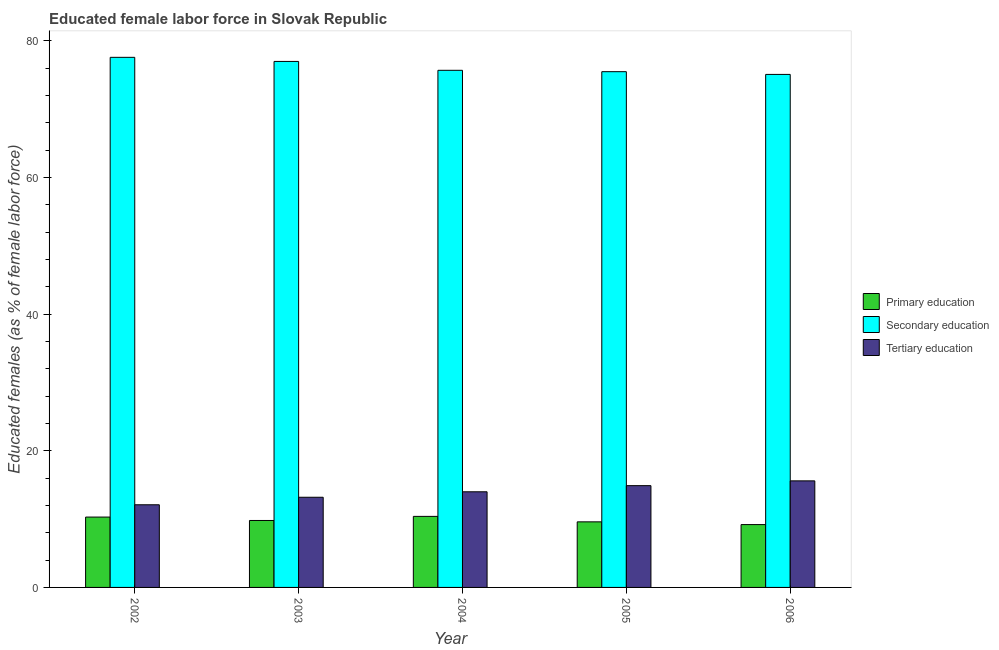How many different coloured bars are there?
Your answer should be very brief. 3. Are the number of bars per tick equal to the number of legend labels?
Offer a very short reply. Yes. Are the number of bars on each tick of the X-axis equal?
Offer a terse response. Yes. How many bars are there on the 5th tick from the left?
Your answer should be compact. 3. How many bars are there on the 4th tick from the right?
Your response must be concise. 3. What is the percentage of female labor force who received primary education in 2006?
Your answer should be compact. 9.2. Across all years, what is the maximum percentage of female labor force who received secondary education?
Give a very brief answer. 77.6. Across all years, what is the minimum percentage of female labor force who received secondary education?
Your response must be concise. 75.1. In which year was the percentage of female labor force who received primary education maximum?
Give a very brief answer. 2004. What is the total percentage of female labor force who received primary education in the graph?
Keep it short and to the point. 49.3. What is the difference between the percentage of female labor force who received secondary education in 2003 and that in 2006?
Keep it short and to the point. 1.9. What is the difference between the percentage of female labor force who received secondary education in 2004 and the percentage of female labor force who received primary education in 2005?
Keep it short and to the point. 0.2. What is the average percentage of female labor force who received tertiary education per year?
Provide a succinct answer. 13.96. In the year 2002, what is the difference between the percentage of female labor force who received tertiary education and percentage of female labor force who received secondary education?
Keep it short and to the point. 0. In how many years, is the percentage of female labor force who received tertiary education greater than 24 %?
Your answer should be very brief. 0. What is the ratio of the percentage of female labor force who received primary education in 2003 to that in 2006?
Give a very brief answer. 1.07. What is the difference between the highest and the second highest percentage of female labor force who received tertiary education?
Make the answer very short. 0.7. What is the difference between the highest and the lowest percentage of female labor force who received secondary education?
Make the answer very short. 2.5. What does the 3rd bar from the left in 2004 represents?
Provide a short and direct response. Tertiary education. What is the difference between two consecutive major ticks on the Y-axis?
Your answer should be very brief. 20. Are the values on the major ticks of Y-axis written in scientific E-notation?
Ensure brevity in your answer.  No. Does the graph contain grids?
Your response must be concise. No. How many legend labels are there?
Your answer should be very brief. 3. What is the title of the graph?
Your answer should be compact. Educated female labor force in Slovak Republic. What is the label or title of the X-axis?
Provide a succinct answer. Year. What is the label or title of the Y-axis?
Your response must be concise. Educated females (as % of female labor force). What is the Educated females (as % of female labor force) of Primary education in 2002?
Give a very brief answer. 10.3. What is the Educated females (as % of female labor force) of Secondary education in 2002?
Ensure brevity in your answer.  77.6. What is the Educated females (as % of female labor force) of Tertiary education in 2002?
Your response must be concise. 12.1. What is the Educated females (as % of female labor force) in Primary education in 2003?
Offer a terse response. 9.8. What is the Educated females (as % of female labor force) in Secondary education in 2003?
Give a very brief answer. 77. What is the Educated females (as % of female labor force) in Tertiary education in 2003?
Make the answer very short. 13.2. What is the Educated females (as % of female labor force) in Primary education in 2004?
Give a very brief answer. 10.4. What is the Educated females (as % of female labor force) of Secondary education in 2004?
Ensure brevity in your answer.  75.7. What is the Educated females (as % of female labor force) of Tertiary education in 2004?
Offer a terse response. 14. What is the Educated females (as % of female labor force) of Primary education in 2005?
Your answer should be compact. 9.6. What is the Educated females (as % of female labor force) of Secondary education in 2005?
Your answer should be compact. 75.5. What is the Educated females (as % of female labor force) in Tertiary education in 2005?
Your answer should be very brief. 14.9. What is the Educated females (as % of female labor force) of Primary education in 2006?
Offer a terse response. 9.2. What is the Educated females (as % of female labor force) of Secondary education in 2006?
Offer a very short reply. 75.1. What is the Educated females (as % of female labor force) in Tertiary education in 2006?
Give a very brief answer. 15.6. Across all years, what is the maximum Educated females (as % of female labor force) in Primary education?
Provide a succinct answer. 10.4. Across all years, what is the maximum Educated females (as % of female labor force) of Secondary education?
Offer a terse response. 77.6. Across all years, what is the maximum Educated females (as % of female labor force) of Tertiary education?
Offer a terse response. 15.6. Across all years, what is the minimum Educated females (as % of female labor force) of Primary education?
Ensure brevity in your answer.  9.2. Across all years, what is the minimum Educated females (as % of female labor force) in Secondary education?
Your answer should be very brief. 75.1. Across all years, what is the minimum Educated females (as % of female labor force) in Tertiary education?
Your response must be concise. 12.1. What is the total Educated females (as % of female labor force) of Primary education in the graph?
Keep it short and to the point. 49.3. What is the total Educated females (as % of female labor force) of Secondary education in the graph?
Your answer should be very brief. 380.9. What is the total Educated females (as % of female labor force) of Tertiary education in the graph?
Offer a terse response. 69.8. What is the difference between the Educated females (as % of female labor force) in Primary education in 2002 and that in 2004?
Offer a terse response. -0.1. What is the difference between the Educated females (as % of female labor force) of Secondary education in 2002 and that in 2004?
Provide a succinct answer. 1.9. What is the difference between the Educated females (as % of female labor force) of Primary education in 2002 and that in 2005?
Your response must be concise. 0.7. What is the difference between the Educated females (as % of female labor force) in Secondary education in 2002 and that in 2005?
Offer a terse response. 2.1. What is the difference between the Educated females (as % of female labor force) in Tertiary education in 2002 and that in 2005?
Ensure brevity in your answer.  -2.8. What is the difference between the Educated females (as % of female labor force) in Primary education in 2002 and that in 2006?
Provide a short and direct response. 1.1. What is the difference between the Educated females (as % of female labor force) of Tertiary education in 2002 and that in 2006?
Your answer should be compact. -3.5. What is the difference between the Educated females (as % of female labor force) in Primary education in 2003 and that in 2004?
Offer a very short reply. -0.6. What is the difference between the Educated females (as % of female labor force) in Primary education in 2003 and that in 2005?
Your response must be concise. 0.2. What is the difference between the Educated females (as % of female labor force) of Tertiary education in 2003 and that in 2005?
Provide a short and direct response. -1.7. What is the difference between the Educated females (as % of female labor force) in Primary education in 2003 and that in 2006?
Offer a terse response. 0.6. What is the difference between the Educated females (as % of female labor force) in Secondary education in 2003 and that in 2006?
Provide a short and direct response. 1.9. What is the difference between the Educated females (as % of female labor force) in Tertiary education in 2003 and that in 2006?
Your answer should be very brief. -2.4. What is the difference between the Educated females (as % of female labor force) in Tertiary education in 2004 and that in 2006?
Your answer should be compact. -1.6. What is the difference between the Educated females (as % of female labor force) of Primary education in 2005 and that in 2006?
Your response must be concise. 0.4. What is the difference between the Educated females (as % of female labor force) in Primary education in 2002 and the Educated females (as % of female labor force) in Secondary education in 2003?
Ensure brevity in your answer.  -66.7. What is the difference between the Educated females (as % of female labor force) of Primary education in 2002 and the Educated females (as % of female labor force) of Tertiary education in 2003?
Your answer should be very brief. -2.9. What is the difference between the Educated females (as % of female labor force) of Secondary education in 2002 and the Educated females (as % of female labor force) of Tertiary education in 2003?
Provide a short and direct response. 64.4. What is the difference between the Educated females (as % of female labor force) in Primary education in 2002 and the Educated females (as % of female labor force) in Secondary education in 2004?
Make the answer very short. -65.4. What is the difference between the Educated females (as % of female labor force) of Secondary education in 2002 and the Educated females (as % of female labor force) of Tertiary education in 2004?
Offer a terse response. 63.6. What is the difference between the Educated females (as % of female labor force) of Primary education in 2002 and the Educated females (as % of female labor force) of Secondary education in 2005?
Give a very brief answer. -65.2. What is the difference between the Educated females (as % of female labor force) in Primary education in 2002 and the Educated females (as % of female labor force) in Tertiary education in 2005?
Provide a succinct answer. -4.6. What is the difference between the Educated females (as % of female labor force) of Secondary education in 2002 and the Educated females (as % of female labor force) of Tertiary education in 2005?
Your answer should be very brief. 62.7. What is the difference between the Educated females (as % of female labor force) in Primary education in 2002 and the Educated females (as % of female labor force) in Secondary education in 2006?
Provide a short and direct response. -64.8. What is the difference between the Educated females (as % of female labor force) in Primary education in 2003 and the Educated females (as % of female labor force) in Secondary education in 2004?
Your answer should be compact. -65.9. What is the difference between the Educated females (as % of female labor force) in Secondary education in 2003 and the Educated females (as % of female labor force) in Tertiary education in 2004?
Make the answer very short. 63. What is the difference between the Educated females (as % of female labor force) of Primary education in 2003 and the Educated females (as % of female labor force) of Secondary education in 2005?
Provide a succinct answer. -65.7. What is the difference between the Educated females (as % of female labor force) in Primary education in 2003 and the Educated females (as % of female labor force) in Tertiary education in 2005?
Offer a very short reply. -5.1. What is the difference between the Educated females (as % of female labor force) of Secondary education in 2003 and the Educated females (as % of female labor force) of Tertiary education in 2005?
Provide a short and direct response. 62.1. What is the difference between the Educated females (as % of female labor force) of Primary education in 2003 and the Educated females (as % of female labor force) of Secondary education in 2006?
Ensure brevity in your answer.  -65.3. What is the difference between the Educated females (as % of female labor force) of Primary education in 2003 and the Educated females (as % of female labor force) of Tertiary education in 2006?
Your answer should be compact. -5.8. What is the difference between the Educated females (as % of female labor force) in Secondary education in 2003 and the Educated females (as % of female labor force) in Tertiary education in 2006?
Your answer should be compact. 61.4. What is the difference between the Educated females (as % of female labor force) of Primary education in 2004 and the Educated females (as % of female labor force) of Secondary education in 2005?
Your answer should be compact. -65.1. What is the difference between the Educated females (as % of female labor force) in Secondary education in 2004 and the Educated females (as % of female labor force) in Tertiary education in 2005?
Offer a very short reply. 60.8. What is the difference between the Educated females (as % of female labor force) of Primary education in 2004 and the Educated females (as % of female labor force) of Secondary education in 2006?
Give a very brief answer. -64.7. What is the difference between the Educated females (as % of female labor force) of Primary education in 2004 and the Educated females (as % of female labor force) of Tertiary education in 2006?
Your answer should be very brief. -5.2. What is the difference between the Educated females (as % of female labor force) in Secondary education in 2004 and the Educated females (as % of female labor force) in Tertiary education in 2006?
Keep it short and to the point. 60.1. What is the difference between the Educated females (as % of female labor force) of Primary education in 2005 and the Educated females (as % of female labor force) of Secondary education in 2006?
Offer a terse response. -65.5. What is the difference between the Educated females (as % of female labor force) in Primary education in 2005 and the Educated females (as % of female labor force) in Tertiary education in 2006?
Ensure brevity in your answer.  -6. What is the difference between the Educated females (as % of female labor force) of Secondary education in 2005 and the Educated females (as % of female labor force) of Tertiary education in 2006?
Your answer should be very brief. 59.9. What is the average Educated females (as % of female labor force) in Primary education per year?
Ensure brevity in your answer.  9.86. What is the average Educated females (as % of female labor force) of Secondary education per year?
Offer a terse response. 76.18. What is the average Educated females (as % of female labor force) in Tertiary education per year?
Give a very brief answer. 13.96. In the year 2002, what is the difference between the Educated females (as % of female labor force) in Primary education and Educated females (as % of female labor force) in Secondary education?
Make the answer very short. -67.3. In the year 2002, what is the difference between the Educated females (as % of female labor force) in Secondary education and Educated females (as % of female labor force) in Tertiary education?
Provide a succinct answer. 65.5. In the year 2003, what is the difference between the Educated females (as % of female labor force) in Primary education and Educated females (as % of female labor force) in Secondary education?
Provide a succinct answer. -67.2. In the year 2003, what is the difference between the Educated females (as % of female labor force) in Primary education and Educated females (as % of female labor force) in Tertiary education?
Ensure brevity in your answer.  -3.4. In the year 2003, what is the difference between the Educated females (as % of female labor force) of Secondary education and Educated females (as % of female labor force) of Tertiary education?
Your answer should be compact. 63.8. In the year 2004, what is the difference between the Educated females (as % of female labor force) of Primary education and Educated females (as % of female labor force) of Secondary education?
Your response must be concise. -65.3. In the year 2004, what is the difference between the Educated females (as % of female labor force) in Primary education and Educated females (as % of female labor force) in Tertiary education?
Your response must be concise. -3.6. In the year 2004, what is the difference between the Educated females (as % of female labor force) in Secondary education and Educated females (as % of female labor force) in Tertiary education?
Keep it short and to the point. 61.7. In the year 2005, what is the difference between the Educated females (as % of female labor force) in Primary education and Educated females (as % of female labor force) in Secondary education?
Provide a succinct answer. -65.9. In the year 2005, what is the difference between the Educated females (as % of female labor force) of Primary education and Educated females (as % of female labor force) of Tertiary education?
Your answer should be very brief. -5.3. In the year 2005, what is the difference between the Educated females (as % of female labor force) in Secondary education and Educated females (as % of female labor force) in Tertiary education?
Your answer should be compact. 60.6. In the year 2006, what is the difference between the Educated females (as % of female labor force) of Primary education and Educated females (as % of female labor force) of Secondary education?
Keep it short and to the point. -65.9. In the year 2006, what is the difference between the Educated females (as % of female labor force) in Secondary education and Educated females (as % of female labor force) in Tertiary education?
Your response must be concise. 59.5. What is the ratio of the Educated females (as % of female labor force) in Primary education in 2002 to that in 2003?
Give a very brief answer. 1.05. What is the ratio of the Educated females (as % of female labor force) of Secondary education in 2002 to that in 2004?
Make the answer very short. 1.03. What is the ratio of the Educated females (as % of female labor force) of Tertiary education in 2002 to that in 2004?
Make the answer very short. 0.86. What is the ratio of the Educated females (as % of female labor force) in Primary education in 2002 to that in 2005?
Make the answer very short. 1.07. What is the ratio of the Educated females (as % of female labor force) in Secondary education in 2002 to that in 2005?
Your answer should be very brief. 1.03. What is the ratio of the Educated females (as % of female labor force) of Tertiary education in 2002 to that in 2005?
Keep it short and to the point. 0.81. What is the ratio of the Educated females (as % of female labor force) of Primary education in 2002 to that in 2006?
Give a very brief answer. 1.12. What is the ratio of the Educated females (as % of female labor force) of Secondary education in 2002 to that in 2006?
Your response must be concise. 1.03. What is the ratio of the Educated females (as % of female labor force) of Tertiary education in 2002 to that in 2006?
Provide a succinct answer. 0.78. What is the ratio of the Educated females (as % of female labor force) in Primary education in 2003 to that in 2004?
Make the answer very short. 0.94. What is the ratio of the Educated females (as % of female labor force) in Secondary education in 2003 to that in 2004?
Your answer should be compact. 1.02. What is the ratio of the Educated females (as % of female labor force) in Tertiary education in 2003 to that in 2004?
Keep it short and to the point. 0.94. What is the ratio of the Educated females (as % of female labor force) in Primary education in 2003 to that in 2005?
Give a very brief answer. 1.02. What is the ratio of the Educated females (as % of female labor force) in Secondary education in 2003 to that in 2005?
Your response must be concise. 1.02. What is the ratio of the Educated females (as % of female labor force) of Tertiary education in 2003 to that in 2005?
Offer a terse response. 0.89. What is the ratio of the Educated females (as % of female labor force) of Primary education in 2003 to that in 2006?
Your answer should be very brief. 1.07. What is the ratio of the Educated females (as % of female labor force) in Secondary education in 2003 to that in 2006?
Your answer should be very brief. 1.03. What is the ratio of the Educated females (as % of female labor force) of Tertiary education in 2003 to that in 2006?
Provide a succinct answer. 0.85. What is the ratio of the Educated females (as % of female labor force) of Primary education in 2004 to that in 2005?
Ensure brevity in your answer.  1.08. What is the ratio of the Educated females (as % of female labor force) in Secondary education in 2004 to that in 2005?
Keep it short and to the point. 1. What is the ratio of the Educated females (as % of female labor force) in Tertiary education in 2004 to that in 2005?
Ensure brevity in your answer.  0.94. What is the ratio of the Educated females (as % of female labor force) in Primary education in 2004 to that in 2006?
Provide a short and direct response. 1.13. What is the ratio of the Educated females (as % of female labor force) of Tertiary education in 2004 to that in 2006?
Offer a very short reply. 0.9. What is the ratio of the Educated females (as % of female labor force) of Primary education in 2005 to that in 2006?
Offer a very short reply. 1.04. What is the ratio of the Educated females (as % of female labor force) in Secondary education in 2005 to that in 2006?
Give a very brief answer. 1.01. What is the ratio of the Educated females (as % of female labor force) of Tertiary education in 2005 to that in 2006?
Offer a terse response. 0.96. What is the difference between the highest and the second highest Educated females (as % of female labor force) of Tertiary education?
Keep it short and to the point. 0.7. What is the difference between the highest and the lowest Educated females (as % of female labor force) of Secondary education?
Ensure brevity in your answer.  2.5. What is the difference between the highest and the lowest Educated females (as % of female labor force) in Tertiary education?
Your response must be concise. 3.5. 